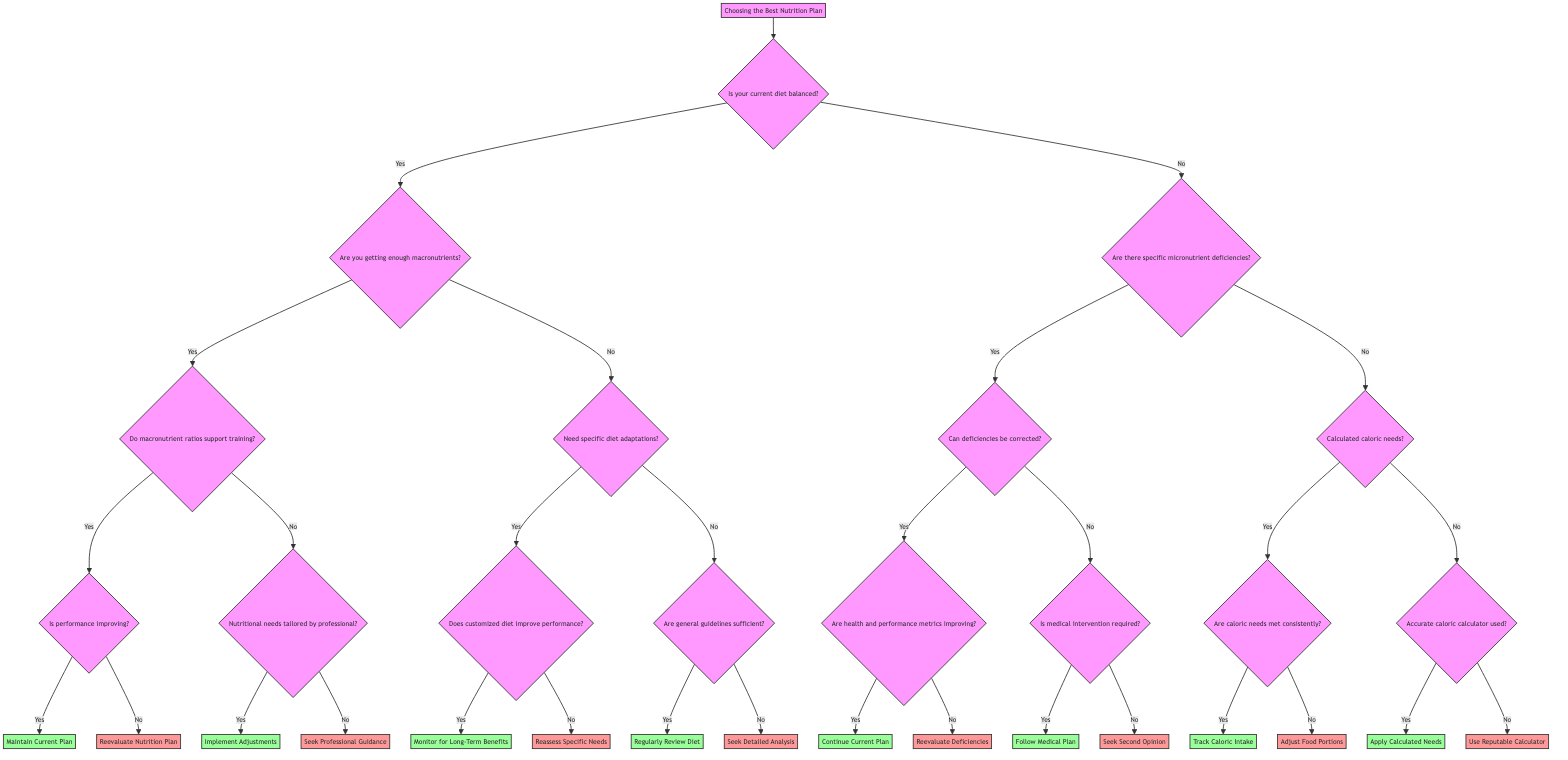What is the first question you need to answer in the diagram? The first question in the decision tree is "Is your current diet balanced?" which is the starting point of the decision process.
Answer: Is your current diet balanced? How many nodes are in the diagram? By counting all the unique sections of the decision tree including the start, questions, and end nodes, we find that there are a total of 20 nodes.
Answer: 20 What do you do if you identify nutritional deficiencies? If there are specific micronutrient deficiencies, the next step is to "Supplement or Adjust Diet" according to the diagram's flow.
Answer: Supplement or Adjust Diet What happens if your performance is not improving? If your performance is not improving, the follow-up action in the decision tree is to "Reevaluate Nutrition Plan" after assessing whether your current macronutrient ratios support your training load.
Answer: Reevaluate Nutrition Plan What is the outcome if adjustments to the diet have been made by a professional? If nutritional needs have been tailored by a professional, the outcome is "Implement Adjustments" to the nutrition plan, indicating a positive resolution to the professional guidance.
Answer: Implement Adjustments What question follows after determining that caloric needs are met consistently? After you confirm that caloric needs are met consistently, the next question is "Are caloric needs met consistently?" which leads to "Track Caloric Intake" if yes.
Answer: Track Caloric Intake 